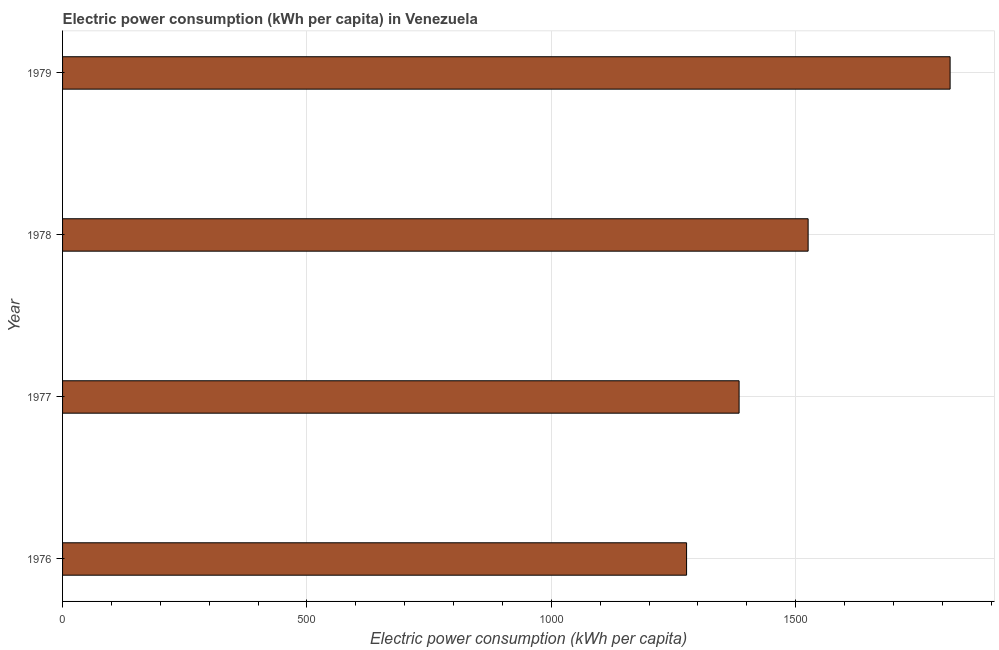Does the graph contain any zero values?
Give a very brief answer. No. What is the title of the graph?
Offer a terse response. Electric power consumption (kWh per capita) in Venezuela. What is the label or title of the X-axis?
Provide a succinct answer. Electric power consumption (kWh per capita). What is the label or title of the Y-axis?
Keep it short and to the point. Year. What is the electric power consumption in 1979?
Provide a succinct answer. 1816. Across all years, what is the maximum electric power consumption?
Your answer should be very brief. 1816. Across all years, what is the minimum electric power consumption?
Provide a short and direct response. 1276.79. In which year was the electric power consumption maximum?
Offer a very short reply. 1979. In which year was the electric power consumption minimum?
Your answer should be very brief. 1976. What is the sum of the electric power consumption?
Offer a very short reply. 6002.49. What is the difference between the electric power consumption in 1977 and 1979?
Give a very brief answer. -431.77. What is the average electric power consumption per year?
Make the answer very short. 1500.62. What is the median electric power consumption?
Provide a succinct answer. 1454.85. What is the ratio of the electric power consumption in 1978 to that in 1979?
Your answer should be compact. 0.84. Is the difference between the electric power consumption in 1977 and 1978 greater than the difference between any two years?
Your response must be concise. No. What is the difference between the highest and the second highest electric power consumption?
Provide a succinct answer. 290.52. What is the difference between the highest and the lowest electric power consumption?
Ensure brevity in your answer.  539.21. In how many years, is the electric power consumption greater than the average electric power consumption taken over all years?
Give a very brief answer. 2. Are all the bars in the graph horizontal?
Offer a very short reply. Yes. How many years are there in the graph?
Your answer should be compact. 4. What is the difference between two consecutive major ticks on the X-axis?
Your response must be concise. 500. What is the Electric power consumption (kWh per capita) of 1976?
Provide a succinct answer. 1276.79. What is the Electric power consumption (kWh per capita) of 1977?
Your response must be concise. 1384.22. What is the Electric power consumption (kWh per capita) in 1978?
Your response must be concise. 1525.48. What is the Electric power consumption (kWh per capita) of 1979?
Keep it short and to the point. 1816. What is the difference between the Electric power consumption (kWh per capita) in 1976 and 1977?
Make the answer very short. -107.43. What is the difference between the Electric power consumption (kWh per capita) in 1976 and 1978?
Offer a very short reply. -248.69. What is the difference between the Electric power consumption (kWh per capita) in 1976 and 1979?
Give a very brief answer. -539.21. What is the difference between the Electric power consumption (kWh per capita) in 1977 and 1978?
Ensure brevity in your answer.  -141.26. What is the difference between the Electric power consumption (kWh per capita) in 1977 and 1979?
Offer a very short reply. -431.78. What is the difference between the Electric power consumption (kWh per capita) in 1978 and 1979?
Your answer should be compact. -290.52. What is the ratio of the Electric power consumption (kWh per capita) in 1976 to that in 1977?
Offer a very short reply. 0.92. What is the ratio of the Electric power consumption (kWh per capita) in 1976 to that in 1978?
Your answer should be compact. 0.84. What is the ratio of the Electric power consumption (kWh per capita) in 1976 to that in 1979?
Your answer should be compact. 0.7. What is the ratio of the Electric power consumption (kWh per capita) in 1977 to that in 1978?
Offer a terse response. 0.91. What is the ratio of the Electric power consumption (kWh per capita) in 1977 to that in 1979?
Make the answer very short. 0.76. What is the ratio of the Electric power consumption (kWh per capita) in 1978 to that in 1979?
Give a very brief answer. 0.84. 